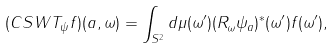Convert formula to latex. <formula><loc_0><loc_0><loc_500><loc_500>( C S W T _ { \psi } f ) ( a , \omega ) = \int _ { S ^ { 2 } } d \mu ( \omega ^ { \prime } ) ( R _ { \omega } \psi _ { a } ) ^ { \ast } ( \omega ^ { \prime } ) f ( \omega ^ { \prime } ) ,</formula> 